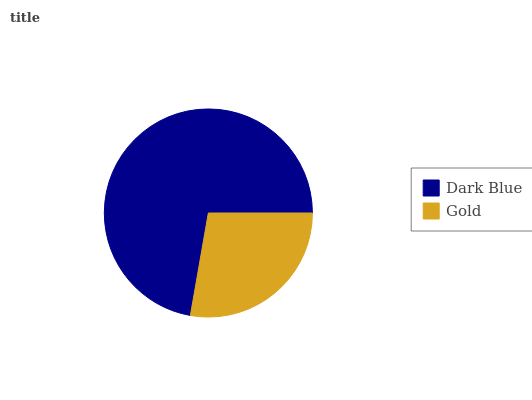Is Gold the minimum?
Answer yes or no. Yes. Is Dark Blue the maximum?
Answer yes or no. Yes. Is Gold the maximum?
Answer yes or no. No. Is Dark Blue greater than Gold?
Answer yes or no. Yes. Is Gold less than Dark Blue?
Answer yes or no. Yes. Is Gold greater than Dark Blue?
Answer yes or no. No. Is Dark Blue less than Gold?
Answer yes or no. No. Is Dark Blue the high median?
Answer yes or no. Yes. Is Gold the low median?
Answer yes or no. Yes. Is Gold the high median?
Answer yes or no. No. Is Dark Blue the low median?
Answer yes or no. No. 